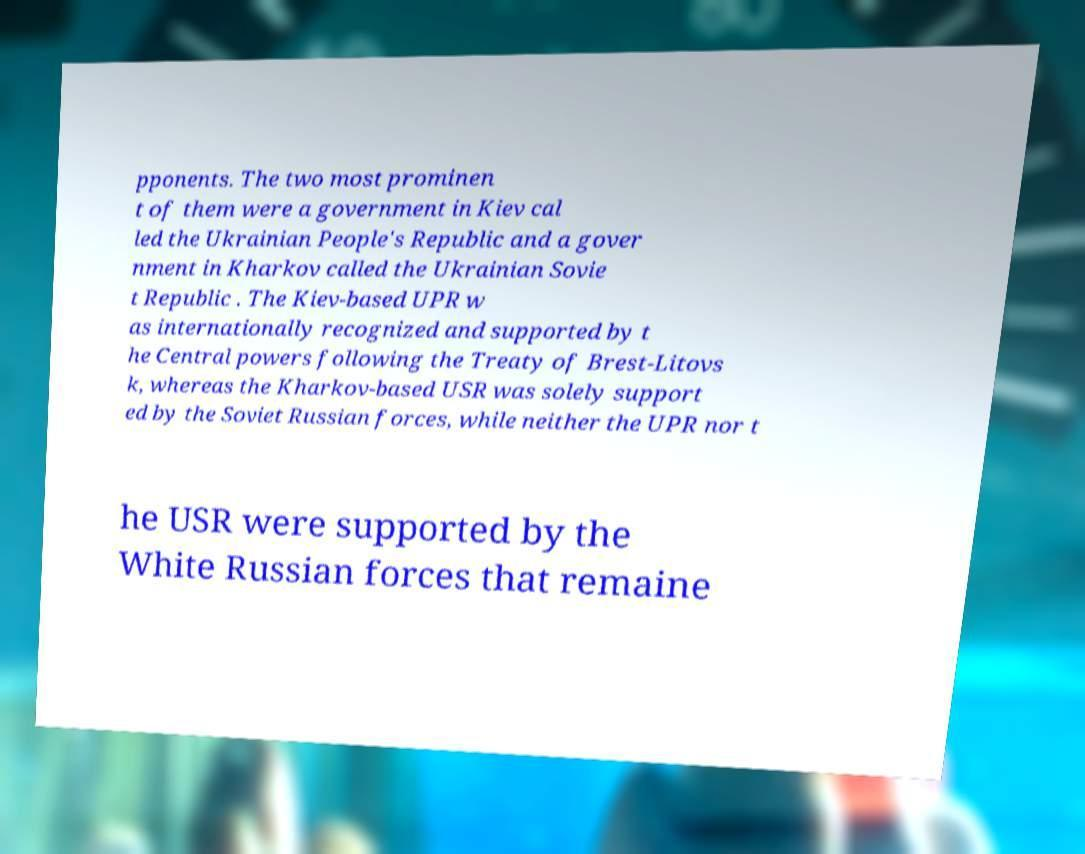For documentation purposes, I need the text within this image transcribed. Could you provide that? pponents. The two most prominen t of them were a government in Kiev cal led the Ukrainian People's Republic and a gover nment in Kharkov called the Ukrainian Sovie t Republic . The Kiev-based UPR w as internationally recognized and supported by t he Central powers following the Treaty of Brest-Litovs k, whereas the Kharkov-based USR was solely support ed by the Soviet Russian forces, while neither the UPR nor t he USR were supported by the White Russian forces that remaine 